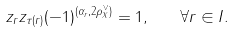<formula> <loc_0><loc_0><loc_500><loc_500>z _ { r } z _ { \tau ( r ) } ( - 1 ) ^ { ( \alpha _ { r } , 2 \rho _ { X } ^ { \vee } ) } = 1 , \quad \forall r \in I .</formula> 